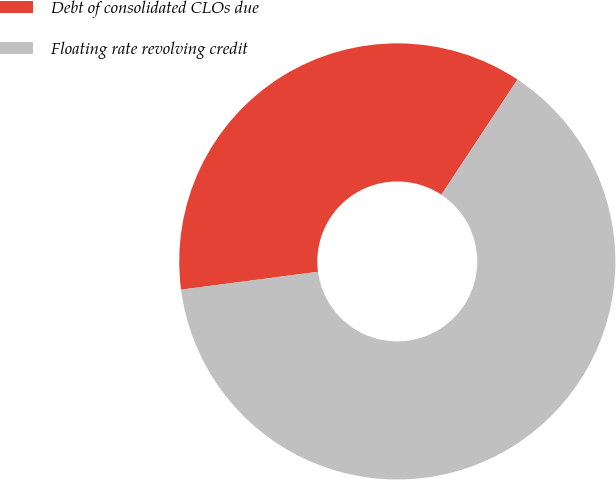Convert chart to OTSL. <chart><loc_0><loc_0><loc_500><loc_500><pie_chart><fcel>Debt of consolidated CLOs due<fcel>Floating rate revolving credit<nl><fcel>36.36%<fcel>63.64%<nl></chart> 